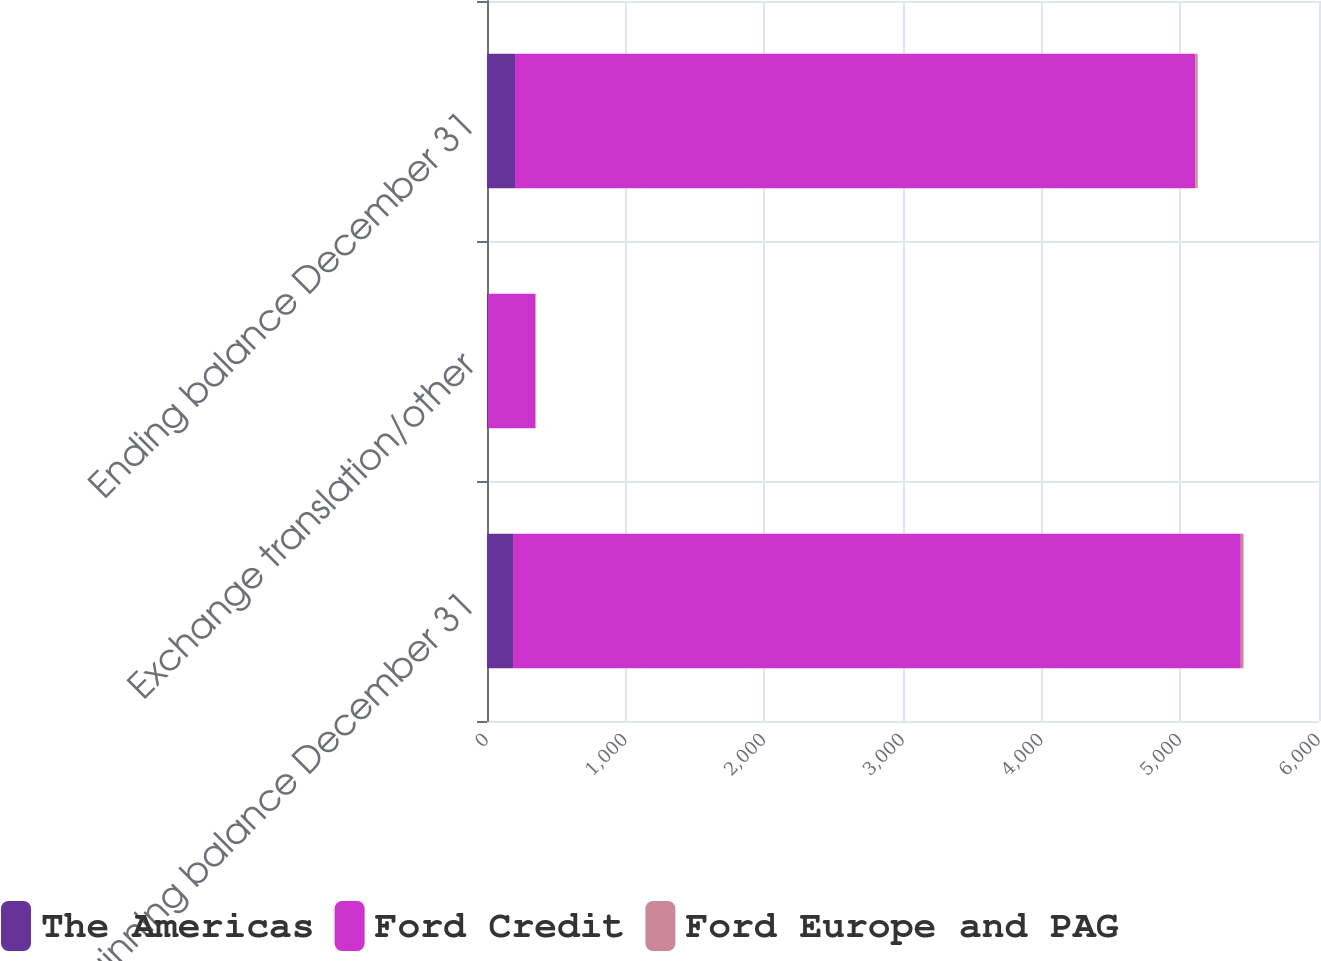Convert chart. <chart><loc_0><loc_0><loc_500><loc_500><stacked_bar_chart><ecel><fcel>Beginning balance December 31<fcel>Exchange translation/other<fcel>Ending balance December 31<nl><fcel>The Americas<fcel>188<fcel>7<fcel>202<nl><fcel>Ford Credit<fcel>5248<fcel>342<fcel>4906<nl><fcel>Ford Europe and PAG<fcel>20<fcel>3<fcel>17<nl></chart> 